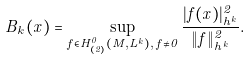<formula> <loc_0><loc_0><loc_500><loc_500>B _ { k } ( x ) = \sup _ { f \in H ^ { 0 } _ { ( 2 ) } ( M , L ^ { k } ) , \, f \neq 0 } \frac { | f ( x ) | ^ { 2 } _ { h ^ { k } } } { \| f \| ^ { 2 } _ { h ^ { k } } } .</formula> 